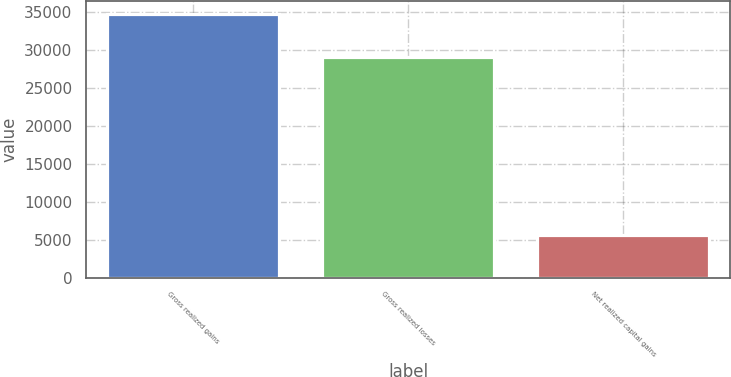Convert chart to OTSL. <chart><loc_0><loc_0><loc_500><loc_500><bar_chart><fcel>Gross realized gains<fcel>Gross realized losses<fcel>Net realized capital gains<nl><fcel>34815<fcel>29169<fcel>5646<nl></chart> 